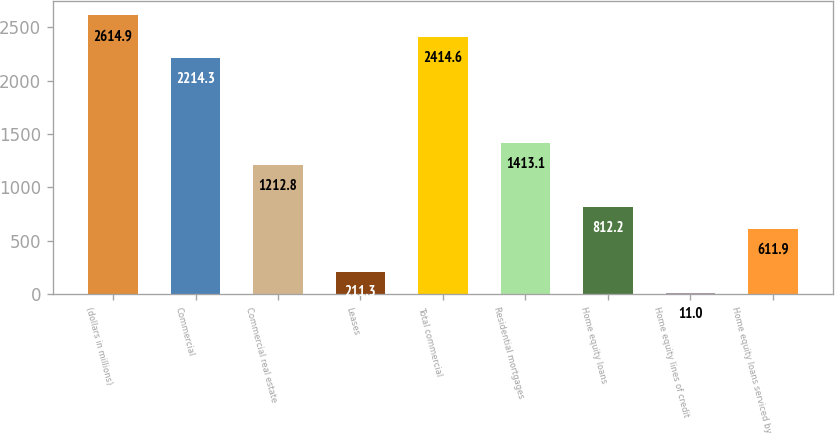Convert chart. <chart><loc_0><loc_0><loc_500><loc_500><bar_chart><fcel>(dollars in millions)<fcel>Commercial<fcel>Commercial real estate<fcel>Leases<fcel>Total commercial<fcel>Residential mortgages<fcel>Home equity loans<fcel>Home equity lines of credit<fcel>Home equity loans serviced by<nl><fcel>2614.9<fcel>2214.3<fcel>1212.8<fcel>211.3<fcel>2414.6<fcel>1413.1<fcel>812.2<fcel>11<fcel>611.9<nl></chart> 